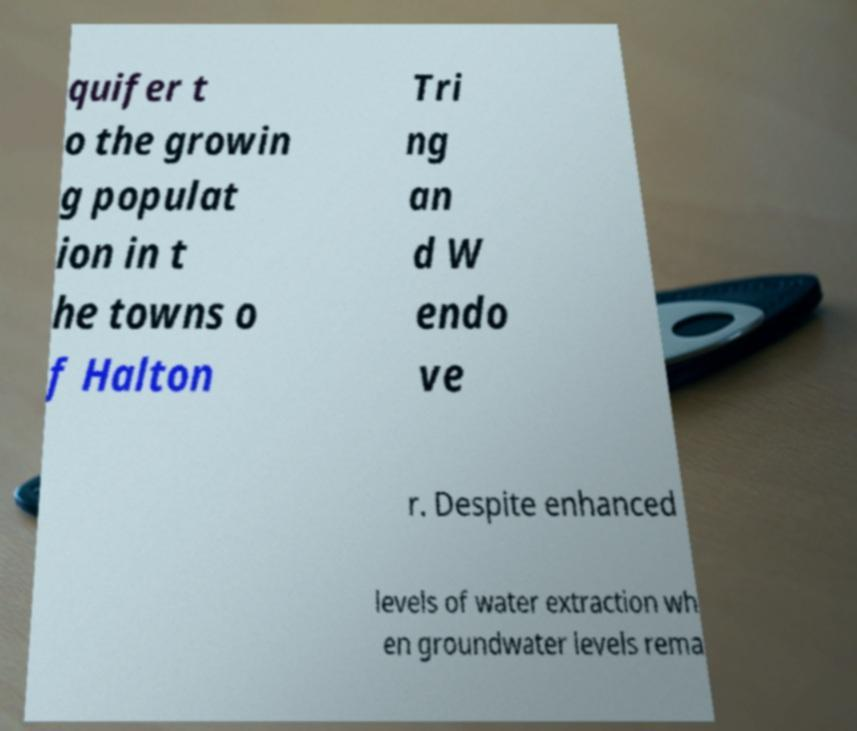Can you accurately transcribe the text from the provided image for me? quifer t o the growin g populat ion in t he towns o f Halton Tri ng an d W endo ve r. Despite enhanced levels of water extraction wh en groundwater levels rema 